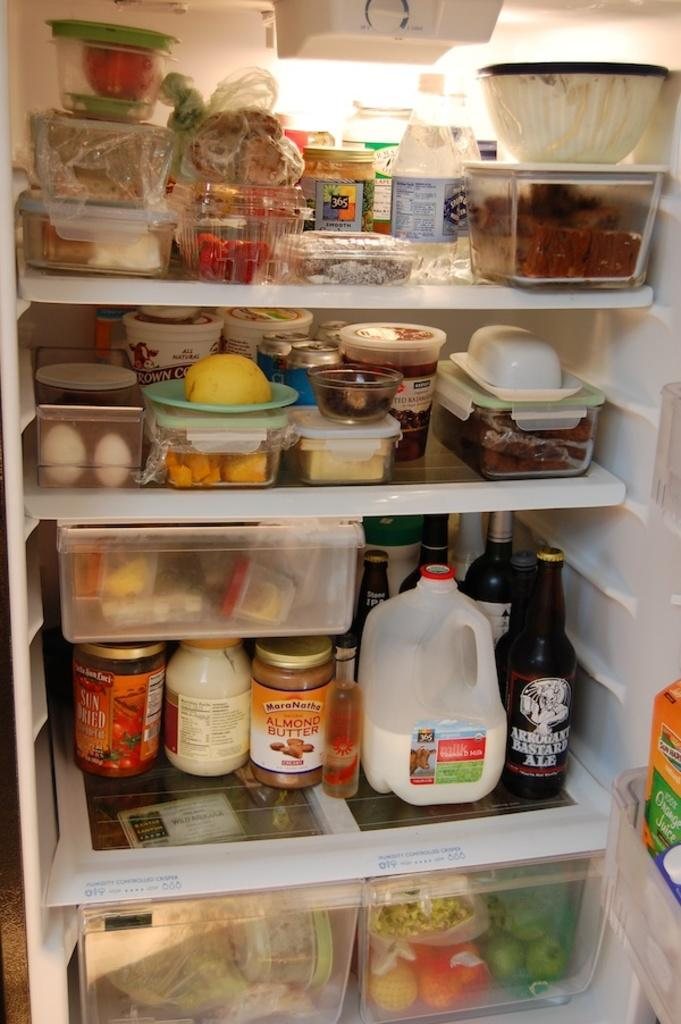<image>
Present a compact description of the photo's key features. the interior of a well stocked fridge include items like Almond Butter 